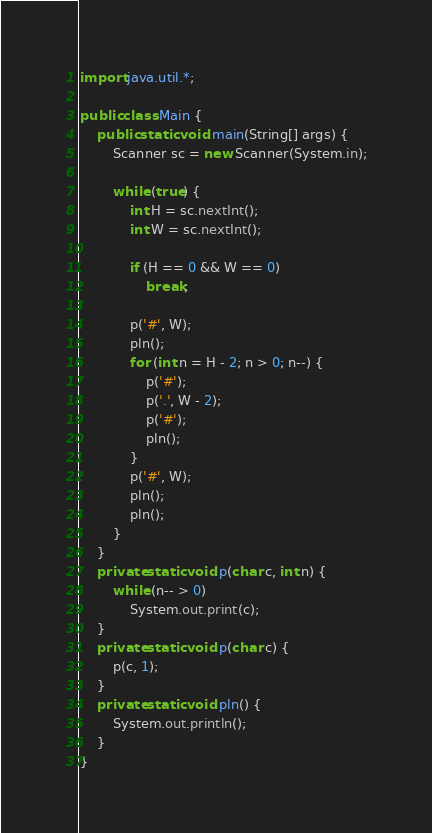Convert code to text. <code><loc_0><loc_0><loc_500><loc_500><_Java_>import java.util.*;

public class Main {
    public static void main(String[] args) {
        Scanner sc = new Scanner(System.in);

        while (true) {
            int H = sc.nextInt();
            int W = sc.nextInt();

            if (H == 0 && W == 0)
                break;

            p('#', W);
            pln();
            for (int n = H - 2; n > 0; n--) {
                p('#');
                p('.', W - 2);
                p('#');
                pln();
            }
            p('#', W);
            pln();
            pln();
        }
    }
    private static void p(char c, int n) {
        while (n-- > 0)
            System.out.print(c);
    }
    private static void p(char c) {
        p(c, 1);
    }
    private static void pln() {
        System.out.println();
    }
}
</code> 